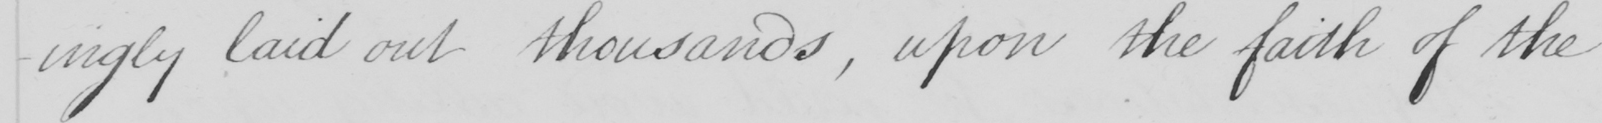What does this handwritten line say? -ingly laid out thousands , upon the faith of the 